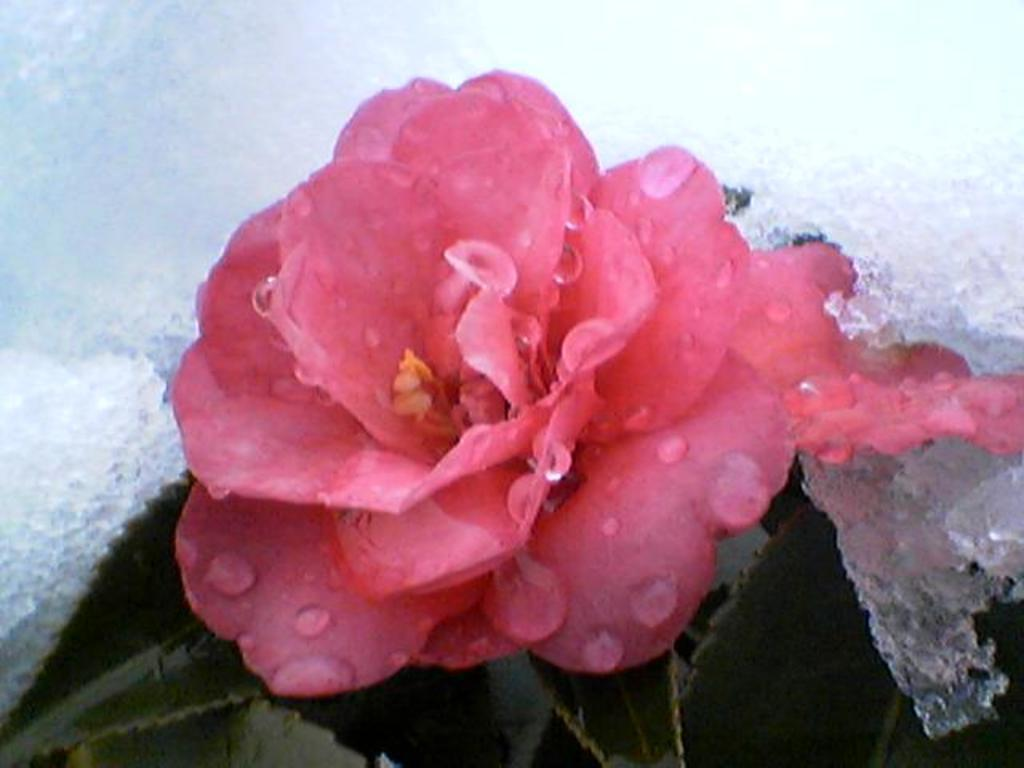What type of flower is in the image? There is a rose flower in the image. What other parts of the rose can be seen in the image? The rose flower has leaves. What is the texture of the ice in the image? The ice is visible in the image. What is the appearance of the water droplets in the image? Water droplets are visible in the image. How many horses are present in the image? There are no horses present in the image. What type of noise can be heard coming from the rose flower in the image? Roses do not make noise, so there is no noise associated with the rose flower in the image. 